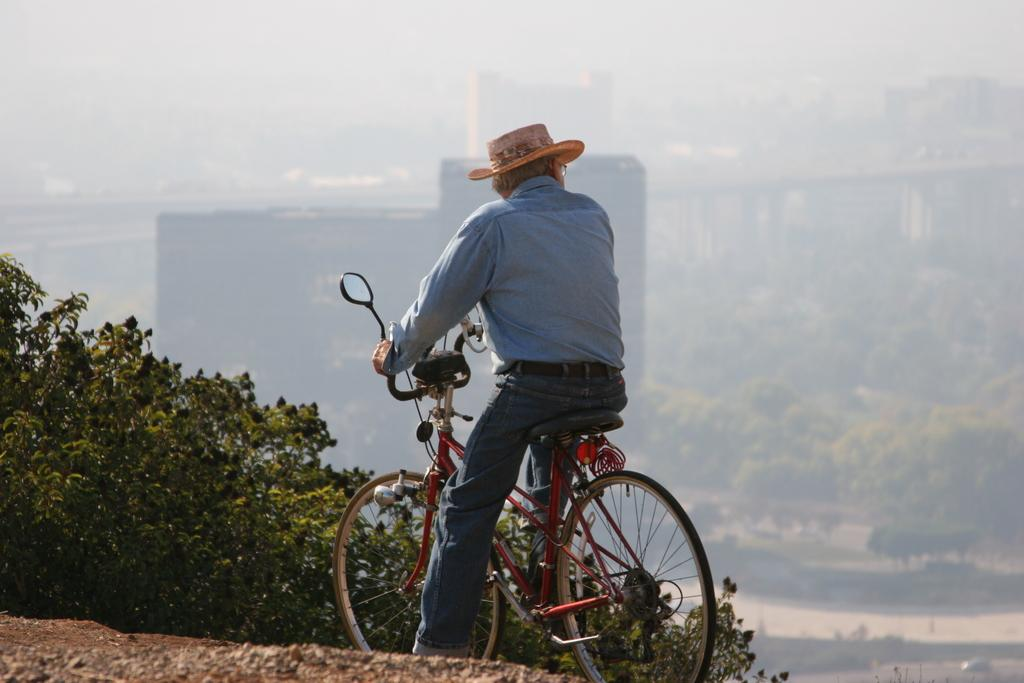What is the main subject of the image? There is a man in the image. What is the man doing in the image? The man is sitting on a bicycle. What can be seen in the background of the image? There are plants, trees, buildings, and the sky visible in the background of the image. Can you describe the person in the background? The man in the background is wearing a hat. What type of plastic is used to make the grain visible in the image? There is no plastic or grain present in the image. 